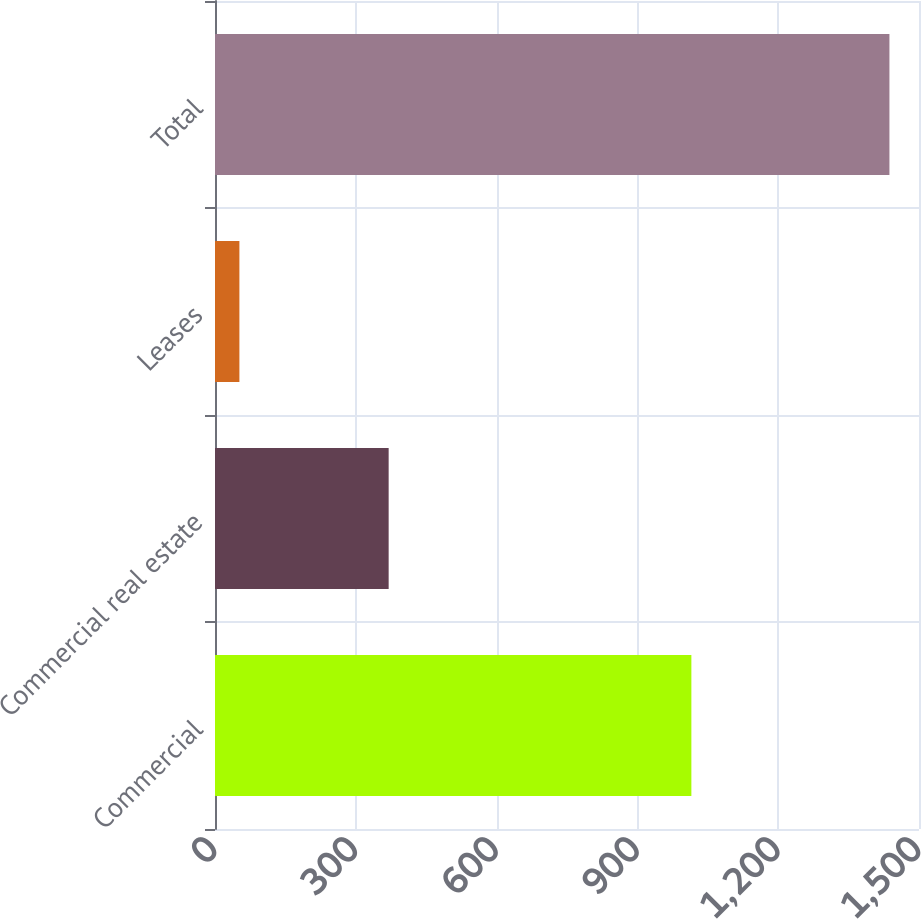<chart> <loc_0><loc_0><loc_500><loc_500><bar_chart><fcel>Commercial<fcel>Commercial real estate<fcel>Leases<fcel>Total<nl><fcel>1015<fcel>370<fcel>52<fcel>1437<nl></chart> 